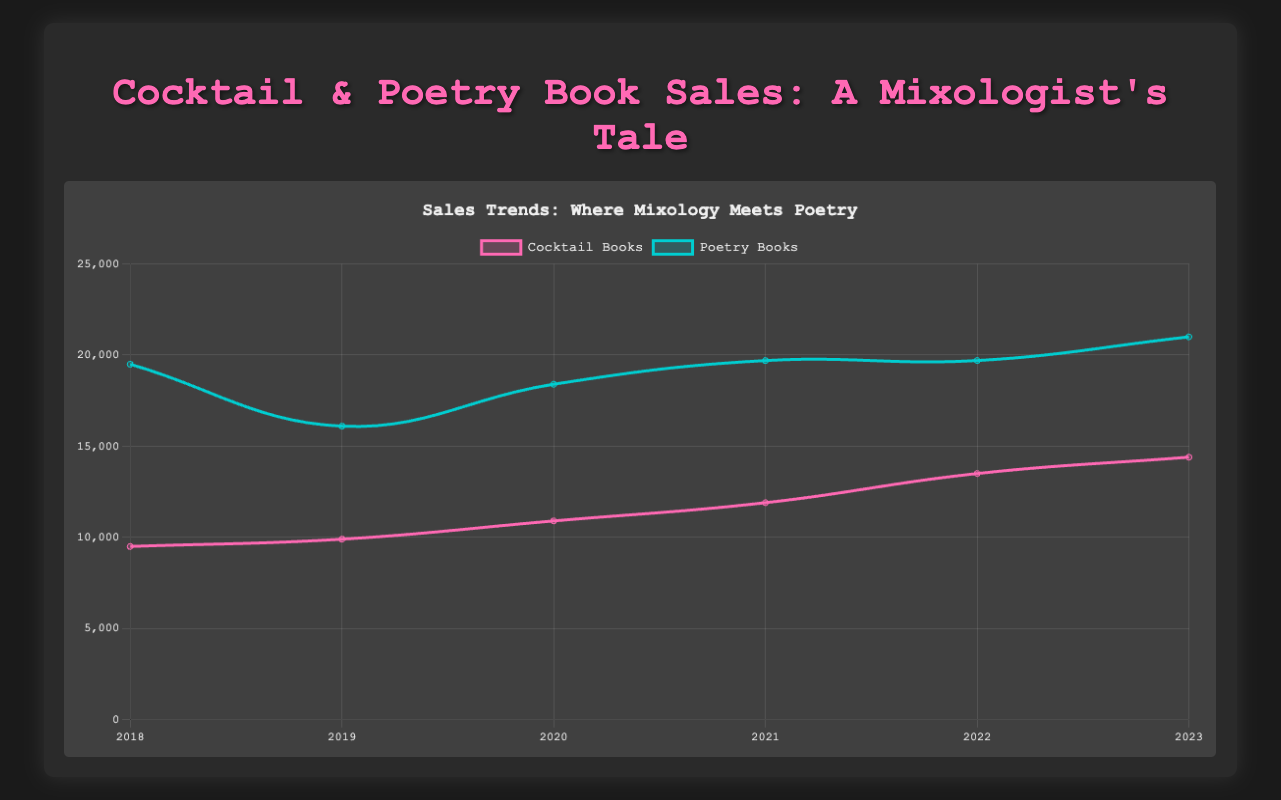What is the overall sales trend for cocktail books from 2018 to 2023? The sales of cocktail books show a consistent upward trend from 2018 to 2023. In 2018 the sales were at 9500, and by 2023 they had increased to 14400. This continuous growth indicates a rising popularity of cocktail books over this period.
Answer: Upward Which year had the highest sales for poetry books? Referring to the figure, the highest sales for poetry books are observed in the year 2023, with a sales total of 21000.
Answer: 2023 Compare the total sales of cocktail books and poetry books in 2020. Which category had higher sales and by how much? In 2020, cocktail books had sales totaling 10900, while poetry books had sales totaling 18400. Poetry books had higher sales by 18400 - 10900 = 7500 units.
Answer: Poetry books, by 7500 units What is the color representation for poetry books in the chart? The line representing poetry books in the chart is colored in a distinct shade of blue, specifically a turquoise or aquamarine color.
Answer: Turquoise Determine the average annual sales for cocktail books from 2019 to 2021. The sales figures for cocktail books from 2019 to 2021 are 9900, 10900, and 11900 respectively. The average is calculated as (9900 + 10900 + 11900) / 3 = 10900.
Answer: 10900 How do the growth patterns of cocktail books and poetry books compare from 2018 to 2023? Both categories show an upward trend over the period. However, the sales of poetry books experienced more fluctuation compared to cocktail books. From 2018 to 2023, the increase for cocktail books is 4900 units (9500 to 14400) while for poetry books it's 1500 units (19500 to 21000). Despite fluctuations, poetry books generally maintain higher sales but with less consistent growth compared to cocktail books.
Answer: Poetry books fluctuated more, but both rose, with cocktails more consistent Which year marks the highest peak for cocktail books and what is the sales figure for that year? The highest peak for cocktail book sales is observed in 2023, with a sales figure of 14400.
Answer: 2023, 14400 Identify the year in which both cocktail and poetry book sales increased significantly from the previous year. Both categories showed significant increases in 2022 compared to 2021. For cocktail books, the increase was from 11900 to 13500, and for poetry books from 19700 to 19700 (no increase). The more significant change for both is from 2021 to 2022.
Answer: 2022 From 2018 to 2023, how much did the sales for cocktail books increase in total? The sales for cocktail books in 2018 were 9500, and by 2023, they increased to 14400. The total increase is calculated as 14400 - 9500 = 4900 units.
Answer: 4900 units What is the difference in sales between cocktail books and poetry books in the year 2018? In 2018, the sales for cocktail books were 9500 and for poetry books were 19500. The difference in sales between the two categories is 19500 - 9500 = 10000 units.
Answer: 10000 units 